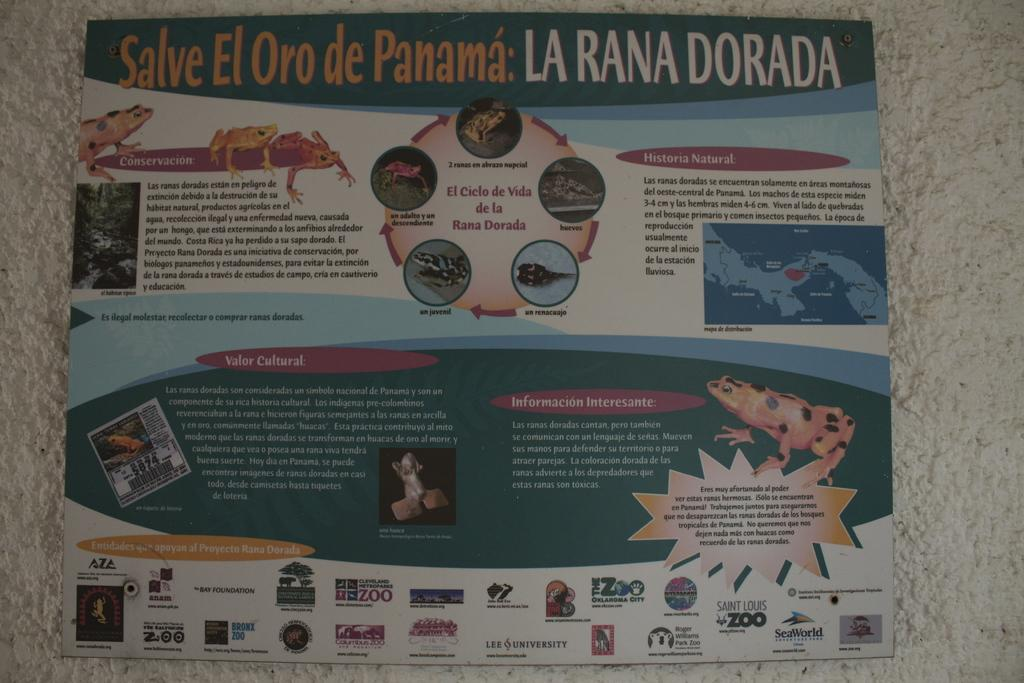Provide a one-sentence caption for the provided image. A brochure for La Rana Dorada featuring various toads and frogs. 